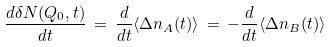Convert formula to latex. <formula><loc_0><loc_0><loc_500><loc_500>\frac { d \delta N ( Q _ { 0 } , t ) } { d t } \, = \, \frac { d } { d t } \langle \Delta n _ { A } ( t ) \rangle \, = \, - \frac { d } { d t } \langle \Delta n _ { B } ( t ) \rangle</formula> 